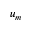Convert formula to latex. <formula><loc_0><loc_0><loc_500><loc_500>u _ { m }</formula> 